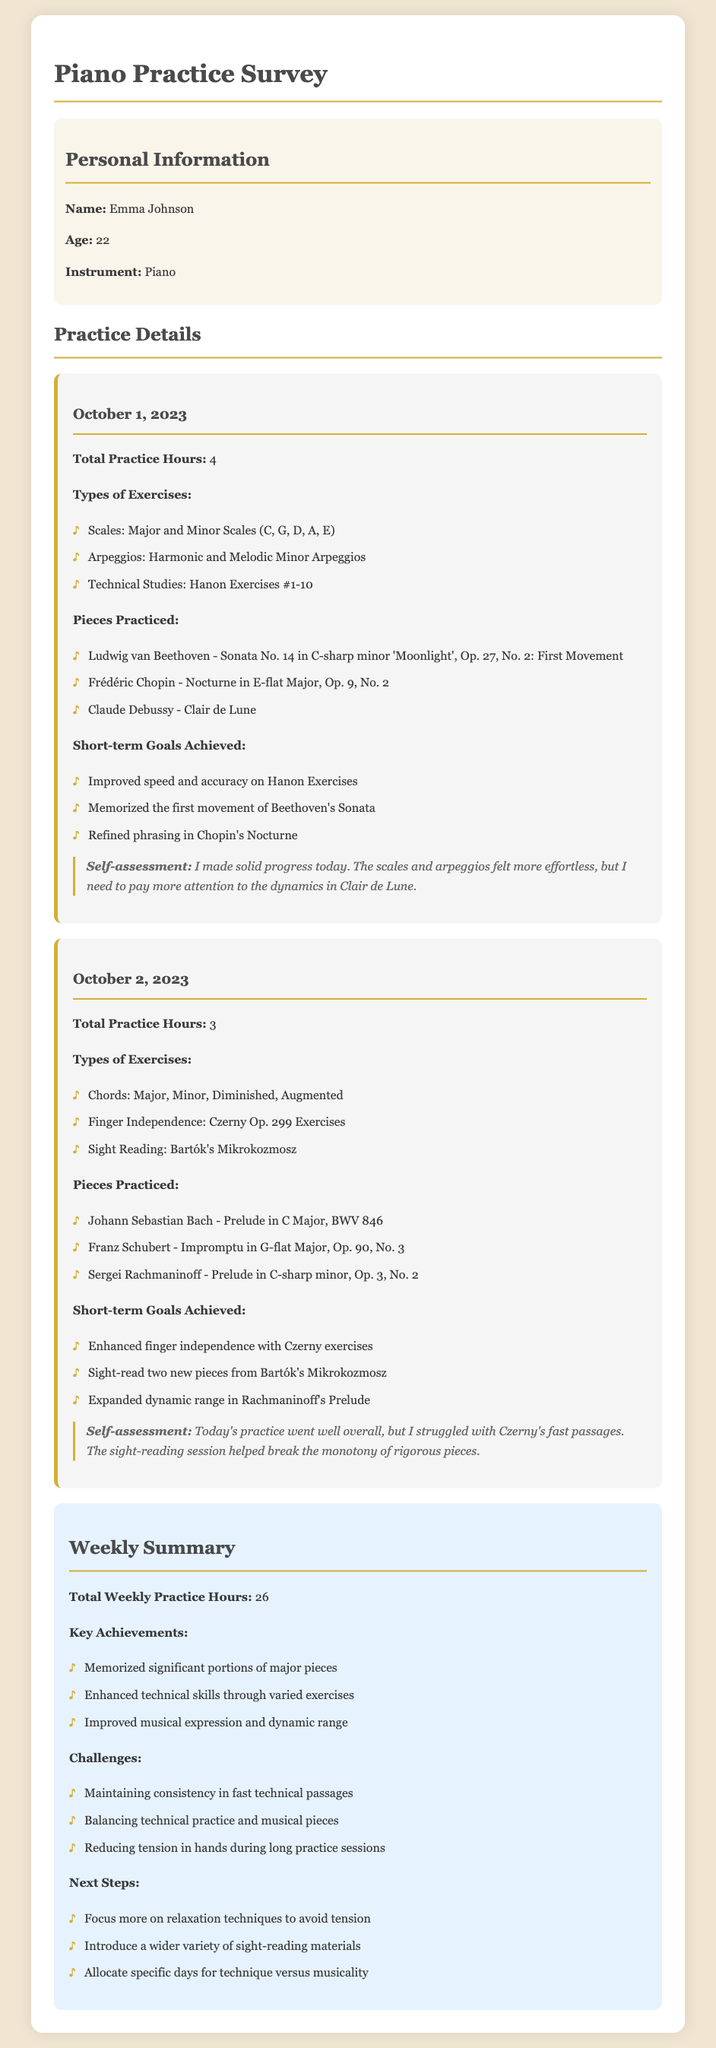What is the name of the pianist? The document states that the pianist's name is Emma Johnson.
Answer: Emma Johnson How many total practice hours were logged on October 1, 2023? The document shows that the total practice hours on October 1, 2023, are listed as 4.
Answer: 4 What three pieces were practiced on October 2, 2023? The document lists Johann Sebastian Bach's Prelude in C Major, Franz Schubert's Impromptu in G-flat Major, and Sergei Rachmaninoff's Prelude in C-sharp minor as the three pieces practiced.
Answer: Prelude in C Major, Impromptu in G-flat Major, Prelude in C-sharp minor What is one of the short-term goals achieved on October 1, 2023? The document mentions that one of the short-term goals achieved on October 1, 2023, was memorizing the first movement of Beethoven's Sonata.
Answer: Memorized the first movement of Beethoven's Sonata What challenges were noted in the weekly summary? The document lists maintaining consistency in fast technical passages, balancing technical practice and musical pieces, and reducing tension in hands during long practice sessions as challenges.
Answer: Maintaining consistency in fast technical passages How many total practice hours were logged for the week? The document states that the total weekly practice hours are 26.
Answer: 26 What is one of the next steps indicated in the weekly summary? The document mentions focusing more on relaxation techniques to avoid tension as one of the next steps.
Answer: Focus more on relaxation techniques What type of exercises were performed on October 2, 2023? The document lists chords, finger independence, and sight reading as the types of exercises performed on this date.
Answer: Chords, Finger Independence, Sight Reading On which date was the first movement of Beethoven's Sonata memorized? The document indicates that the first movement of Beethoven's Sonata was memorized on October 1, 2023.
Answer: October 1, 2023 